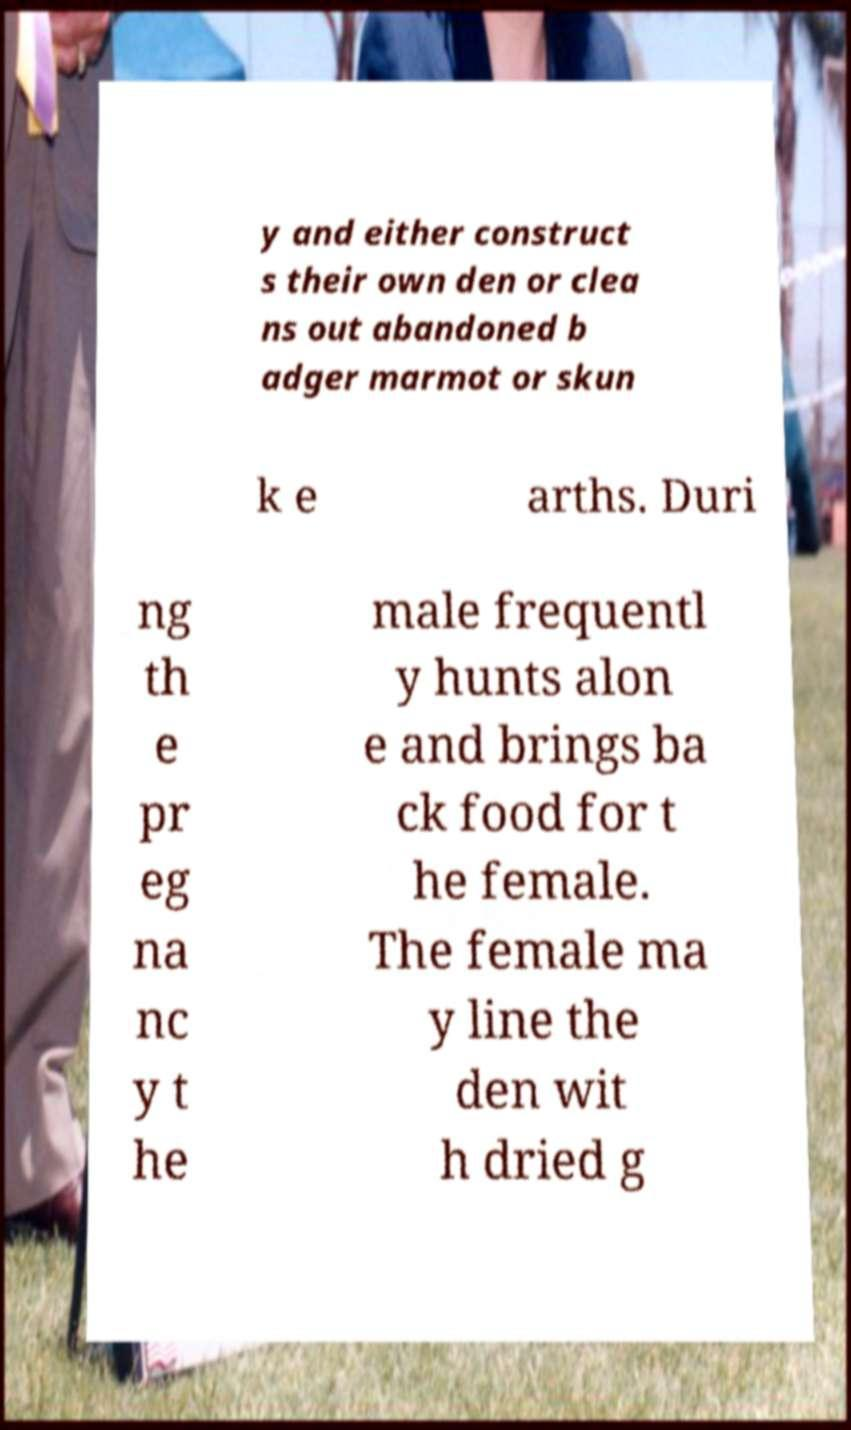Can you read and provide the text displayed in the image?This photo seems to have some interesting text. Can you extract and type it out for me? y and either construct s their own den or clea ns out abandoned b adger marmot or skun k e arths. Duri ng th e pr eg na nc y t he male frequentl y hunts alon e and brings ba ck food for t he female. The female ma y line the den wit h dried g 